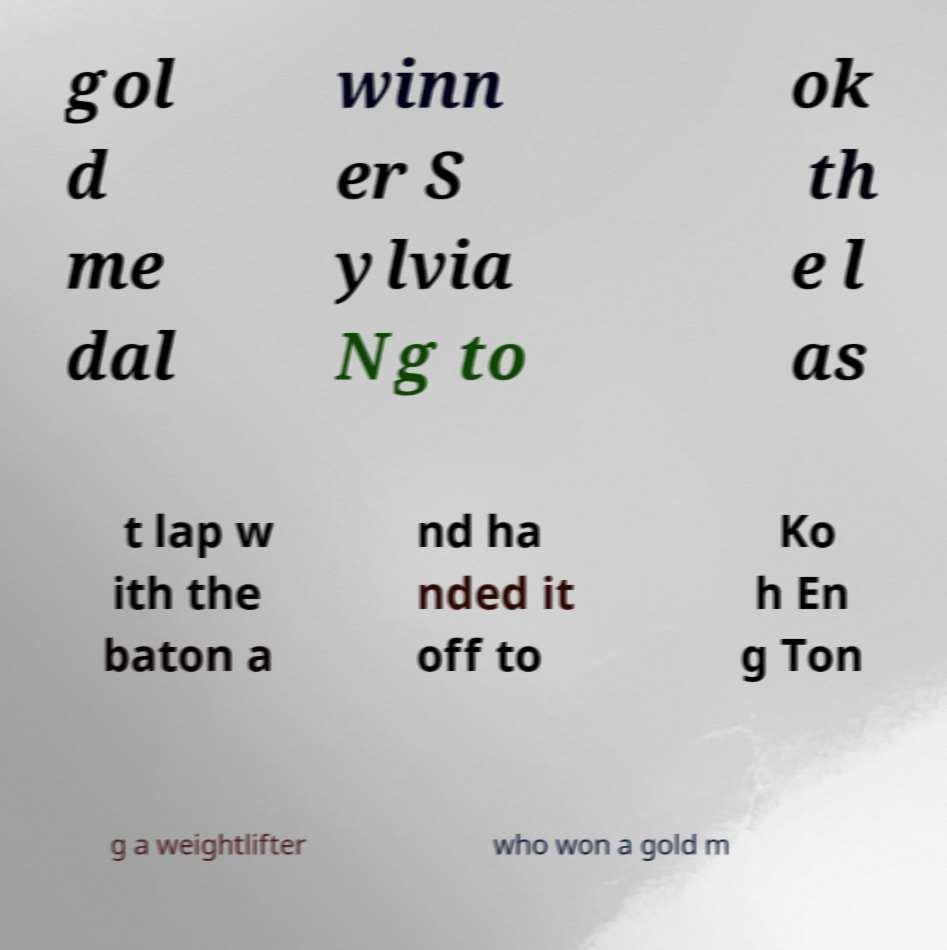There's text embedded in this image that I need extracted. Can you transcribe it verbatim? gol d me dal winn er S ylvia Ng to ok th e l as t lap w ith the baton a nd ha nded it off to Ko h En g Ton g a weightlifter who won a gold m 